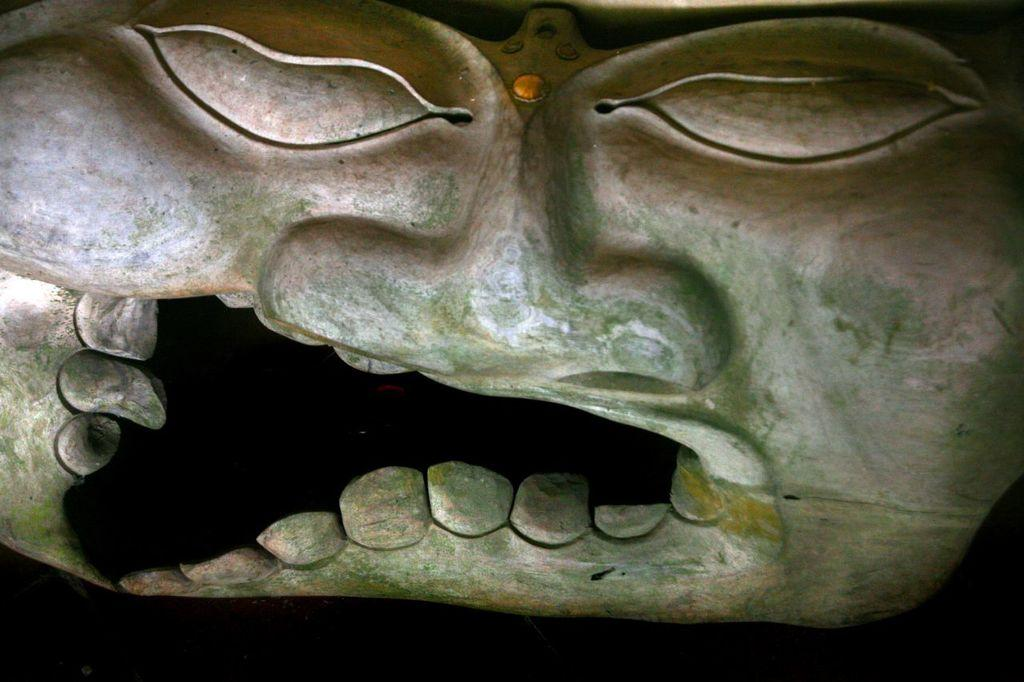What is the main subject of the image? There is a sculpture of a person's face in the image. What color is the background of the image? The background of the image is black in color. Can you tell me how many babies are playing with the yoke in the image? There are no babies or yokes present in the image; it features a sculpture of a person's face with a black background. 